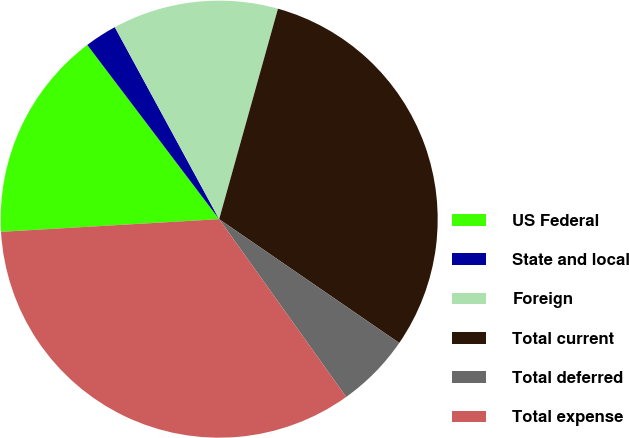<chart> <loc_0><loc_0><loc_500><loc_500><pie_chart><fcel>US Federal<fcel>State and local<fcel>Foreign<fcel>Total current<fcel>Total deferred<fcel>Total expense<nl><fcel>15.61%<fcel>2.39%<fcel>12.26%<fcel>30.25%<fcel>5.54%<fcel>33.95%<nl></chart> 